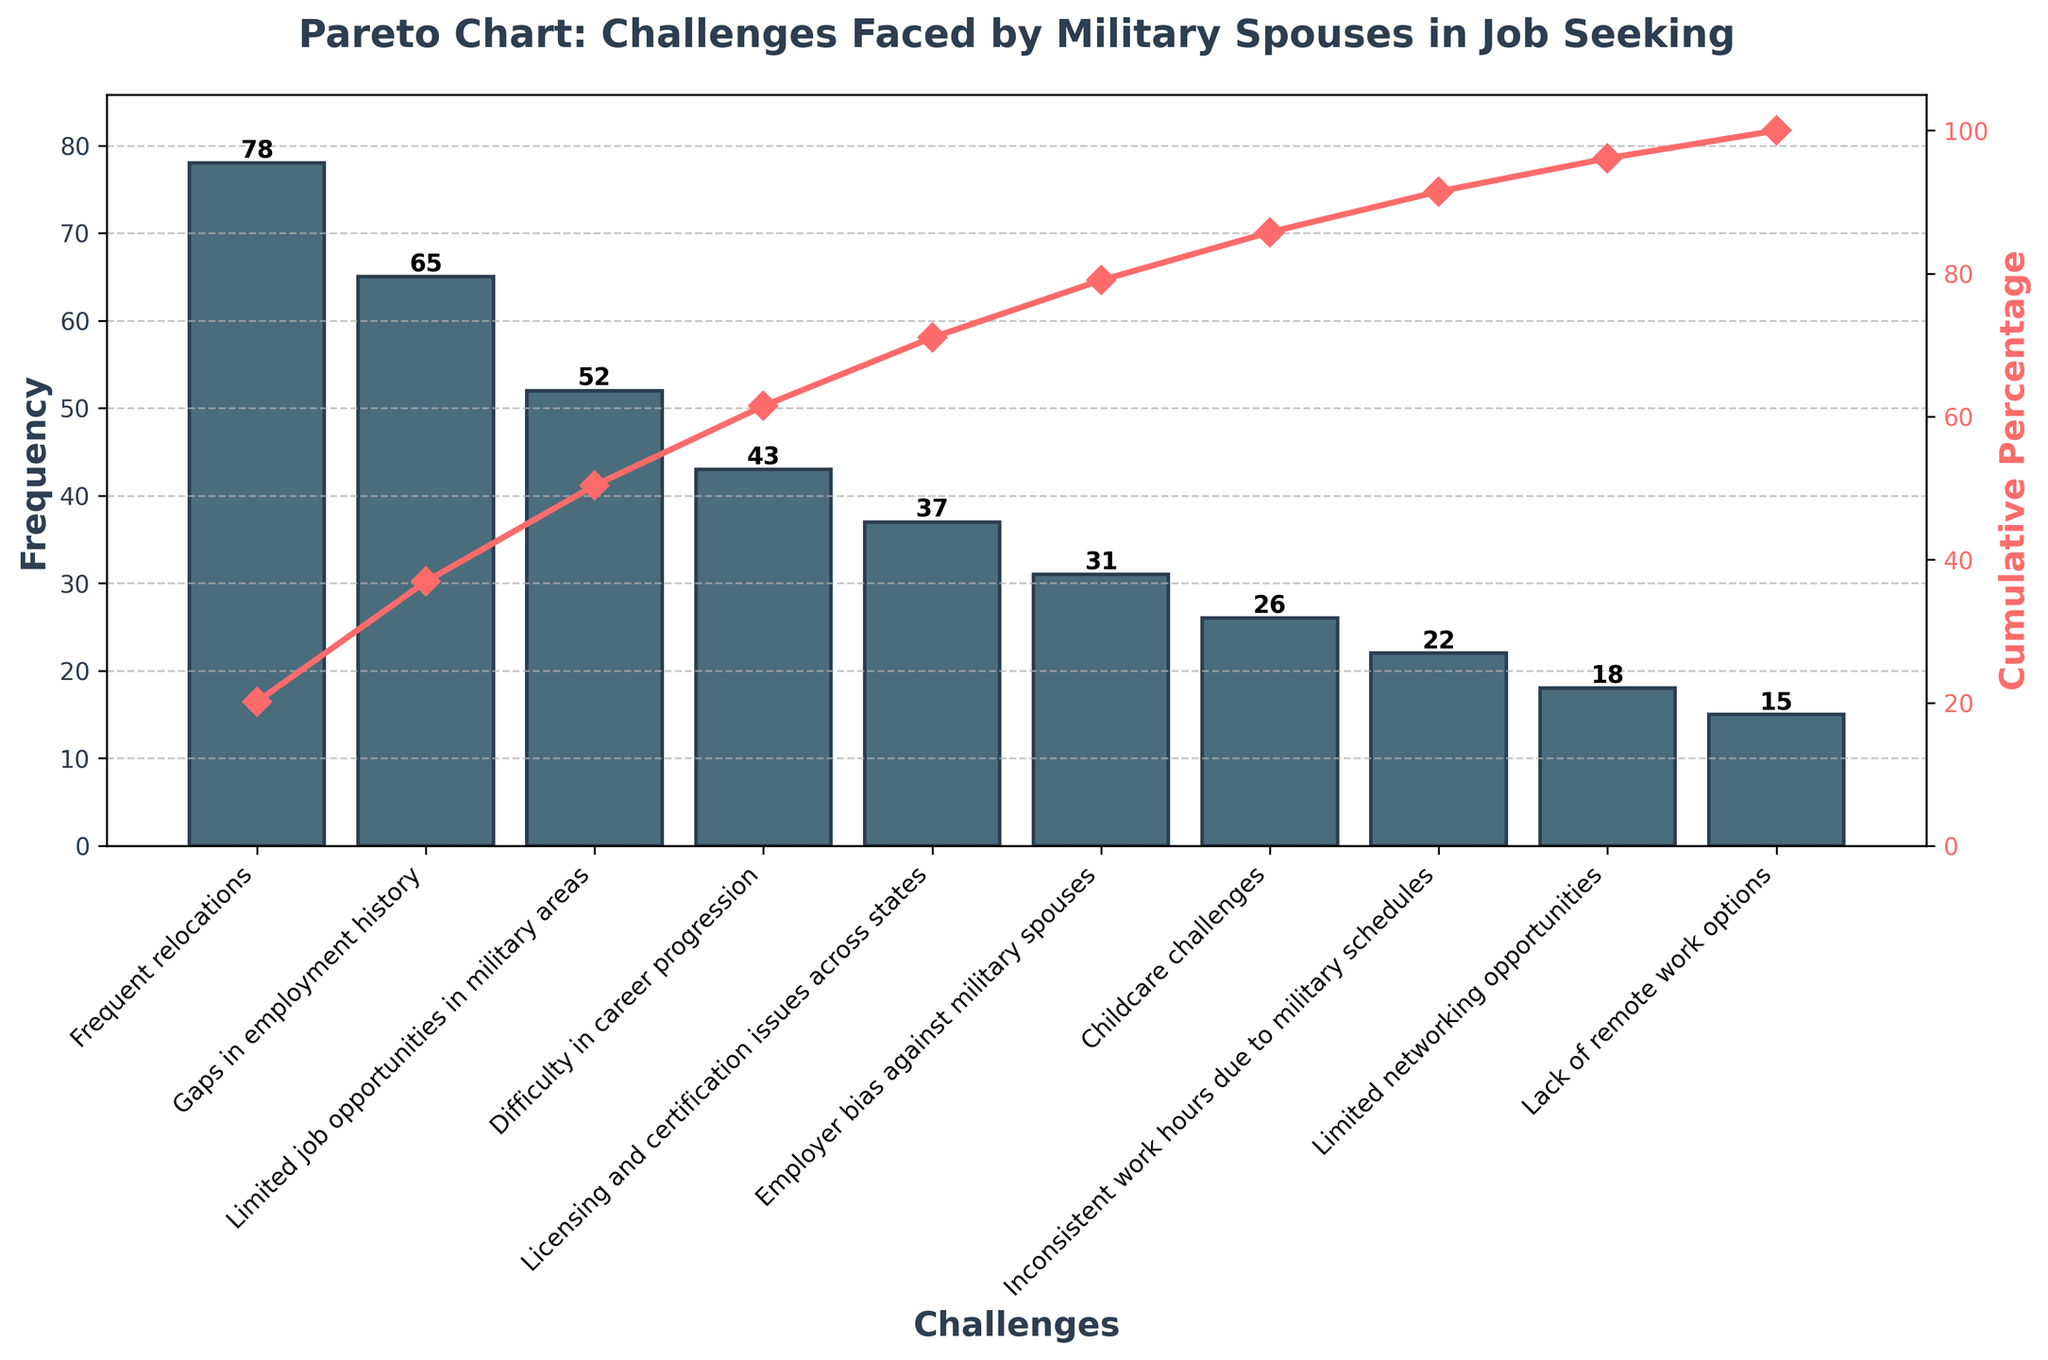What is the title of the chart? The title of the chart is located at the top and clearly states the purpose of the visualization, which helps in understanding the context.
Answer: Pareto Chart: Challenges Faced by Military Spouses in Job Seeking What is the challenge with the highest frequency? The challenge with the highest frequency is identified by looking at the tallest bar on the left side of the chart because the bars are sorted in descending order.
Answer: Frequent relocations How many challenges have a frequency greater than 50? Count the number of bars that exceed the frequency mark of 50 by looking at the y-axis values.
Answer: 3 What is the cumulative percentage for 'Difficulty in career progression'? Find the bar corresponding to 'Difficulty in career progression' and look at the cumulative percentage line (indicated by markers) directly above it.
Answer: 75% Which challenge ranks just below 'Limited job opportunities in military areas'? Identify the bar for 'Limited job opportunities in military areas' and then look at the next bar to its right.
Answer: Difficulty in career progression What is the frequency difference between 'Employer bias against military spouses' and 'Childcare challenges'? Subtract the frequency of 'Childcare challenges' from the frequency of 'Employer bias against military spouses' by examining the heights of the respective bars.
Answer: 5 What cumulative percentage do the top 4 challenges account for? Add the cumulative percentages of the bars corresponding to the top 4 challenges, or directly read off the cumulative percentage marker above the 4th bar, which is 'Difficulty in career progression'.
Answer: 79% Which challenge has a frequency closest to 20? Identify the bar that aligns most closely with the 20 frequency mark on the y-axis.
Answer: Inconsistent work hours due to military schedules Is the cumulative percentage for 'Childcare challenges' greater or less than 65%? Find the bar for 'Childcare challenges' and check if the cumulative percentage line above it crosses the 65% mark.
Answer: Less What is the total frequency of all challenges combined? Sum the frequency values of all the bars by adding the individual heights (frequencies) provided.
Answer: 387 